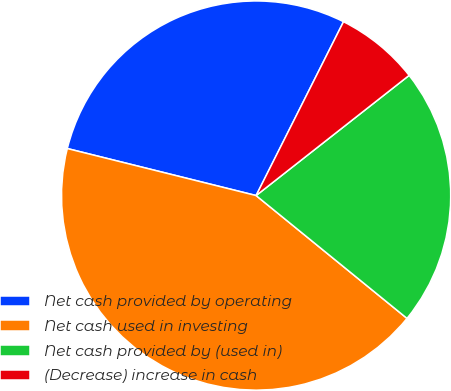Convert chart. <chart><loc_0><loc_0><loc_500><loc_500><pie_chart><fcel>Net cash provided by operating<fcel>Net cash used in investing<fcel>Net cash provided by (used in)<fcel>(Decrease) increase in cash<nl><fcel>28.53%<fcel>43.01%<fcel>21.47%<fcel>6.99%<nl></chart> 